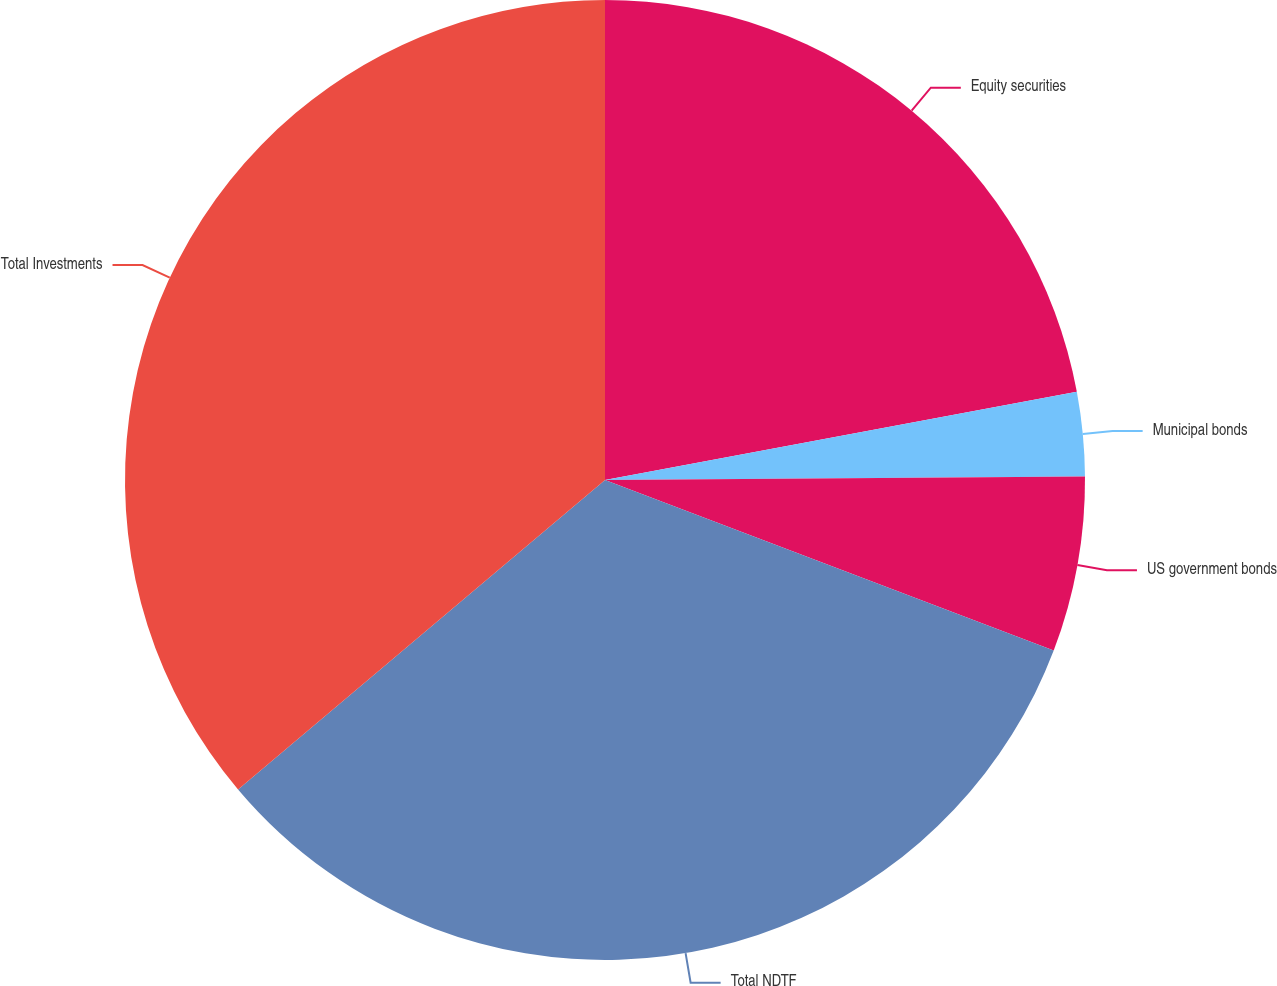<chart> <loc_0><loc_0><loc_500><loc_500><pie_chart><fcel>Equity securities<fcel>Municipal bonds<fcel>US government bonds<fcel>Total NDTF<fcel>Total Investments<nl><fcel>22.06%<fcel>2.82%<fcel>5.9%<fcel>33.07%<fcel>36.15%<nl></chart> 